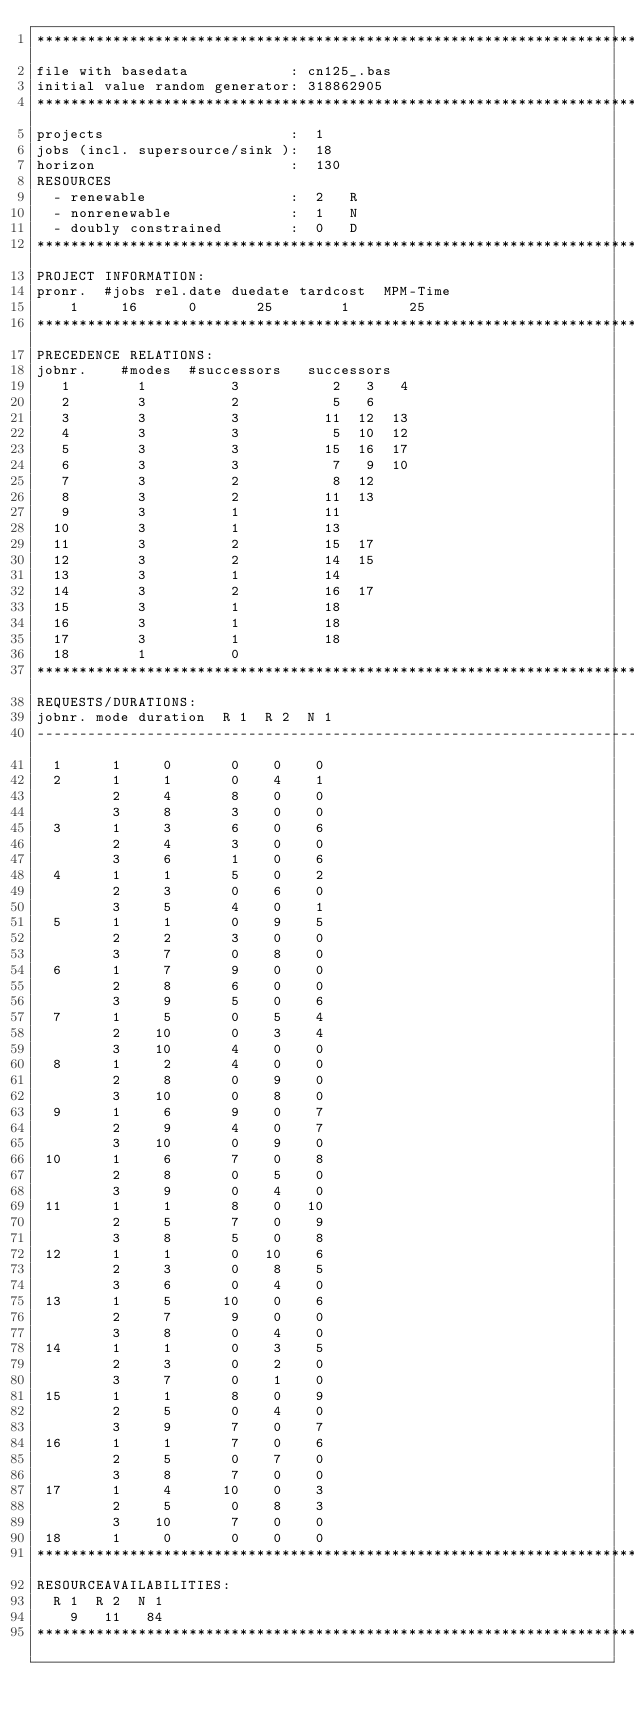Convert code to text. <code><loc_0><loc_0><loc_500><loc_500><_ObjectiveC_>************************************************************************
file with basedata            : cn125_.bas
initial value random generator: 318862905
************************************************************************
projects                      :  1
jobs (incl. supersource/sink ):  18
horizon                       :  130
RESOURCES
  - renewable                 :  2   R
  - nonrenewable              :  1   N
  - doubly constrained        :  0   D
************************************************************************
PROJECT INFORMATION:
pronr.  #jobs rel.date duedate tardcost  MPM-Time
    1     16      0       25        1       25
************************************************************************
PRECEDENCE RELATIONS:
jobnr.    #modes  #successors   successors
   1        1          3           2   3   4
   2        3          2           5   6
   3        3          3          11  12  13
   4        3          3           5  10  12
   5        3          3          15  16  17
   6        3          3           7   9  10
   7        3          2           8  12
   8        3          2          11  13
   9        3          1          11
  10        3          1          13
  11        3          2          15  17
  12        3          2          14  15
  13        3          1          14
  14        3          2          16  17
  15        3          1          18
  16        3          1          18
  17        3          1          18
  18        1          0        
************************************************************************
REQUESTS/DURATIONS:
jobnr. mode duration  R 1  R 2  N 1
------------------------------------------------------------------------
  1      1     0       0    0    0
  2      1     1       0    4    1
         2     4       8    0    0
         3     8       3    0    0
  3      1     3       6    0    6
         2     4       3    0    0
         3     6       1    0    6
  4      1     1       5    0    2
         2     3       0    6    0
         3     5       4    0    1
  5      1     1       0    9    5
         2     2       3    0    0
         3     7       0    8    0
  6      1     7       9    0    0
         2     8       6    0    0
         3     9       5    0    6
  7      1     5       0    5    4
         2    10       0    3    4
         3    10       4    0    0
  8      1     2       4    0    0
         2     8       0    9    0
         3    10       0    8    0
  9      1     6       9    0    7
         2     9       4    0    7
         3    10       0    9    0
 10      1     6       7    0    8
         2     8       0    5    0
         3     9       0    4    0
 11      1     1       8    0   10
         2     5       7    0    9
         3     8       5    0    8
 12      1     1       0   10    6
         2     3       0    8    5
         3     6       0    4    0
 13      1     5      10    0    6
         2     7       9    0    0
         3     8       0    4    0
 14      1     1       0    3    5
         2     3       0    2    0
         3     7       0    1    0
 15      1     1       8    0    9
         2     5       0    4    0
         3     9       7    0    7
 16      1     1       7    0    6
         2     5       0    7    0
         3     8       7    0    0
 17      1     4      10    0    3
         2     5       0    8    3
         3    10       7    0    0
 18      1     0       0    0    0
************************************************************************
RESOURCEAVAILABILITIES:
  R 1  R 2  N 1
    9   11   84
************************************************************************
</code> 